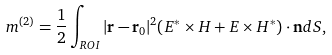Convert formula to latex. <formula><loc_0><loc_0><loc_500><loc_500>m ^ { ( 2 ) } = \frac { 1 } { 2 } \int _ { R O I } | \mathbf r - \mathbf r _ { 0 } | ^ { 2 } ( E ^ { * } \times H + E \times H ^ { * } ) \cdot \mathbf n d S ,</formula> 